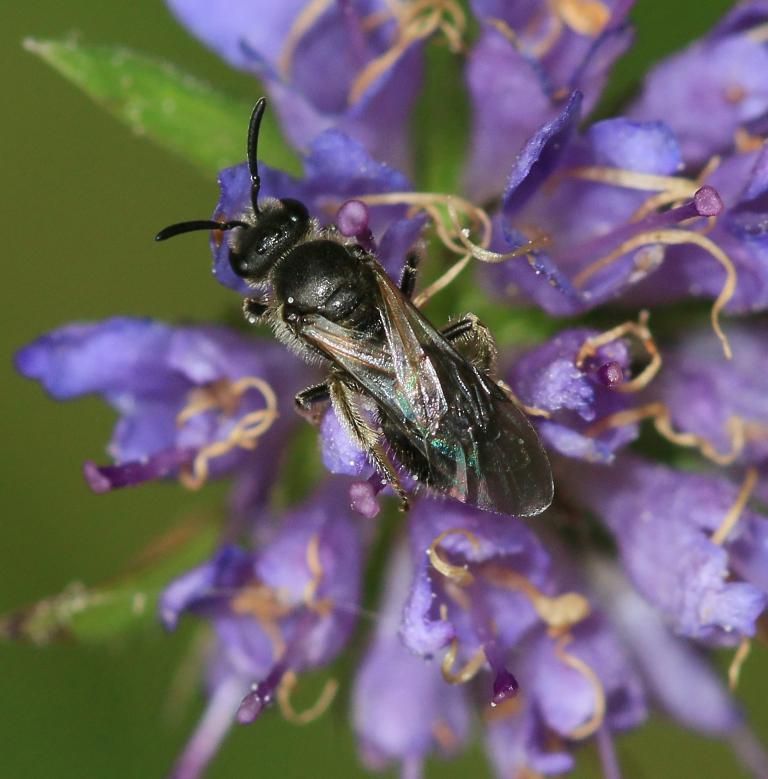Can you describe this image briefly? There is a violet color flower. On that there is an insect. In the background it is green and blurred. 